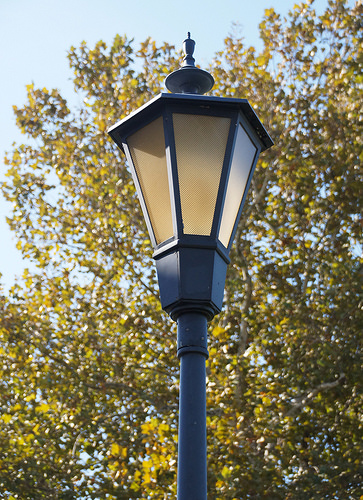<image>
Is there a lantern in front of the tree? Yes. The lantern is positioned in front of the tree, appearing closer to the camera viewpoint. 